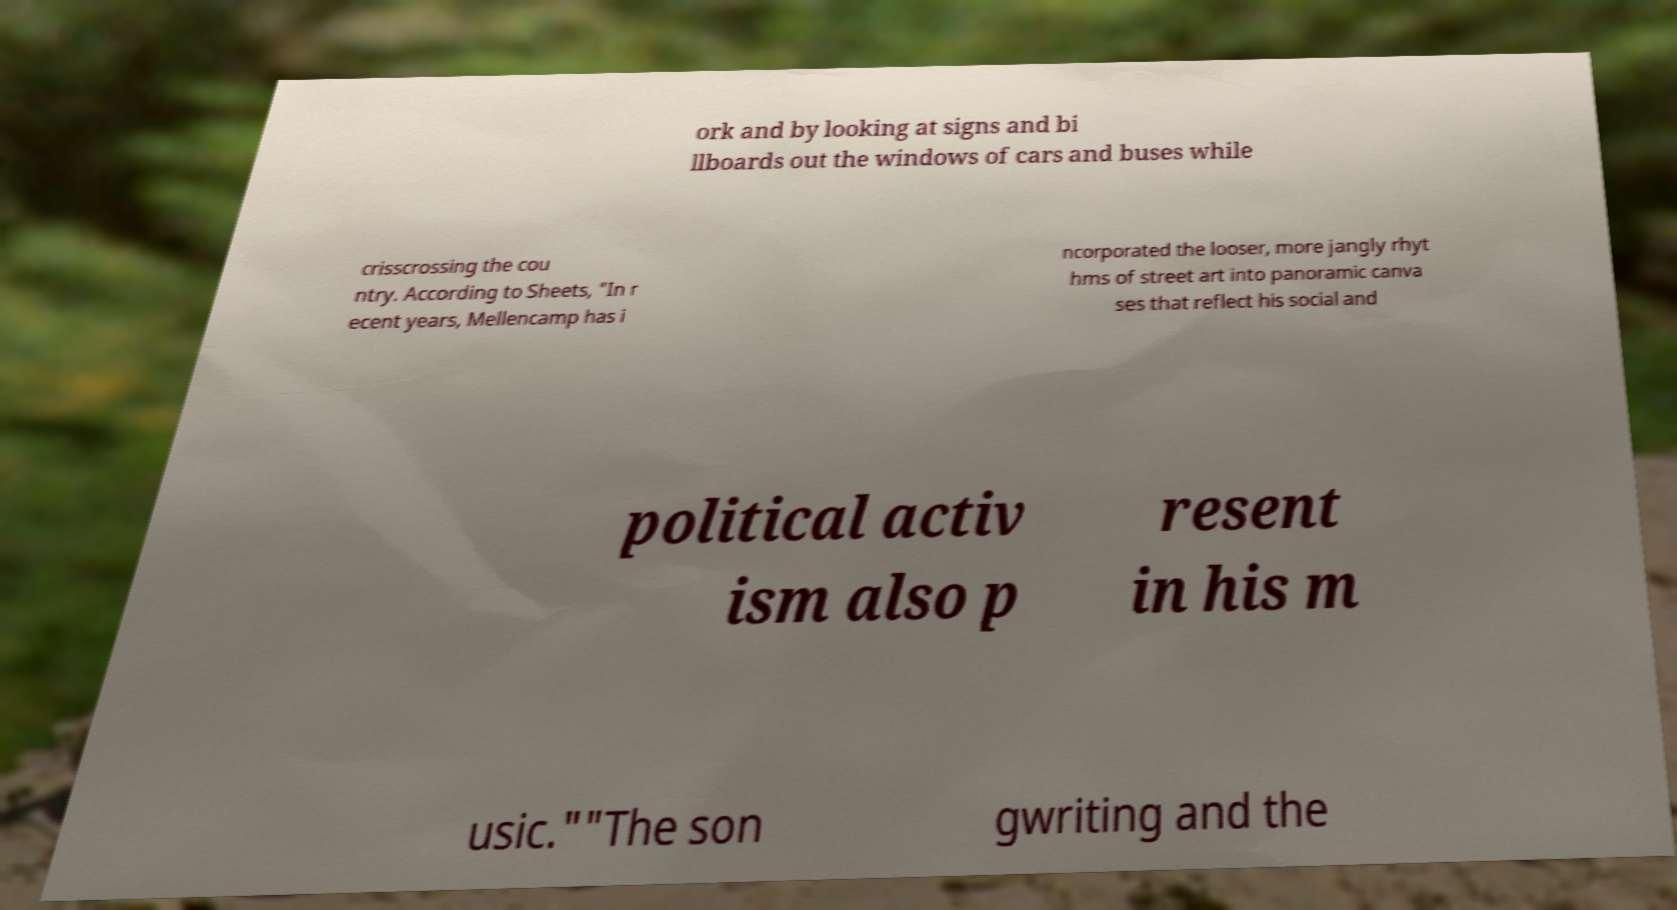Could you assist in decoding the text presented in this image and type it out clearly? ork and by looking at signs and bi llboards out the windows of cars and buses while crisscrossing the cou ntry. According to Sheets, "In r ecent years, Mellencamp has i ncorporated the looser, more jangly rhyt hms of street art into panoramic canva ses that reflect his social and political activ ism also p resent in his m usic.""The son gwriting and the 